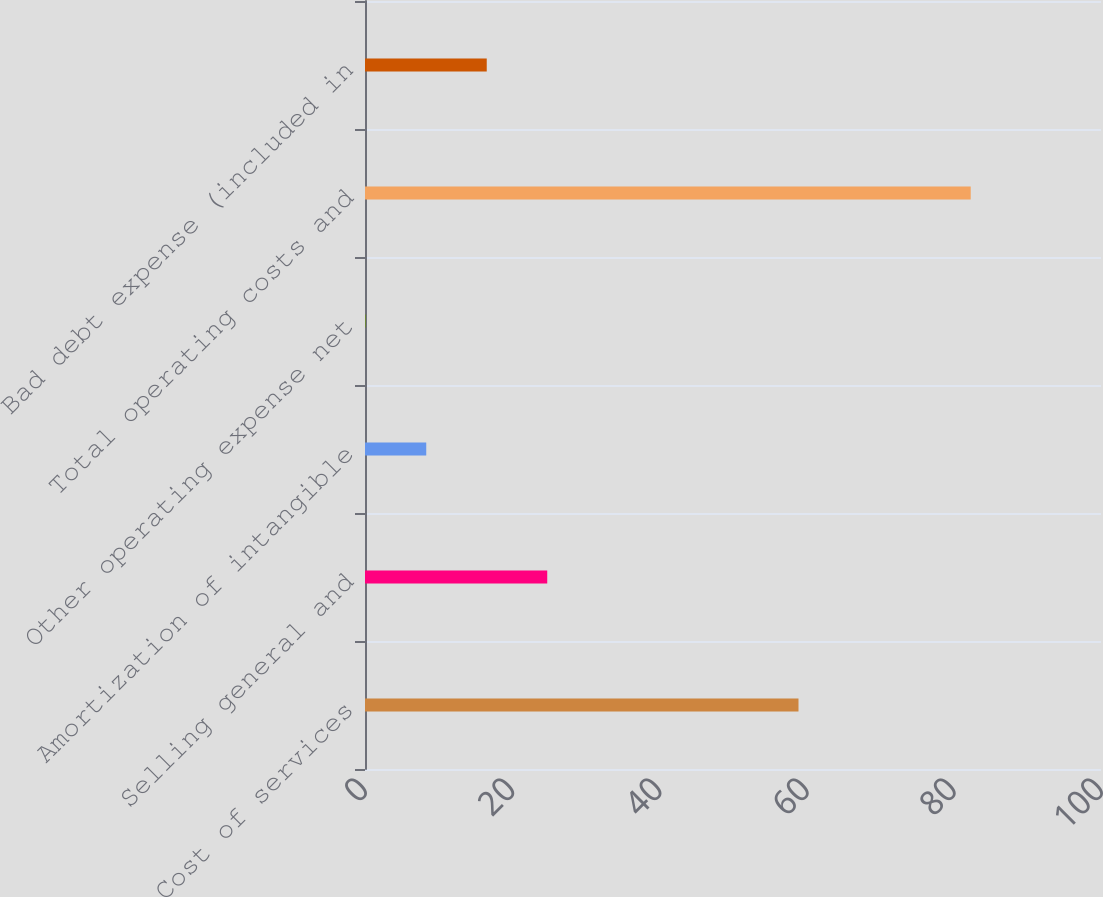<chart> <loc_0><loc_0><loc_500><loc_500><bar_chart><fcel>Cost of services<fcel>Selling general and<fcel>Amortization of intangible<fcel>Other operating expense net<fcel>Total operating costs and<fcel>Bad debt expense (included in<nl><fcel>58.9<fcel>24.76<fcel>8.32<fcel>0.1<fcel>82.3<fcel>16.54<nl></chart> 